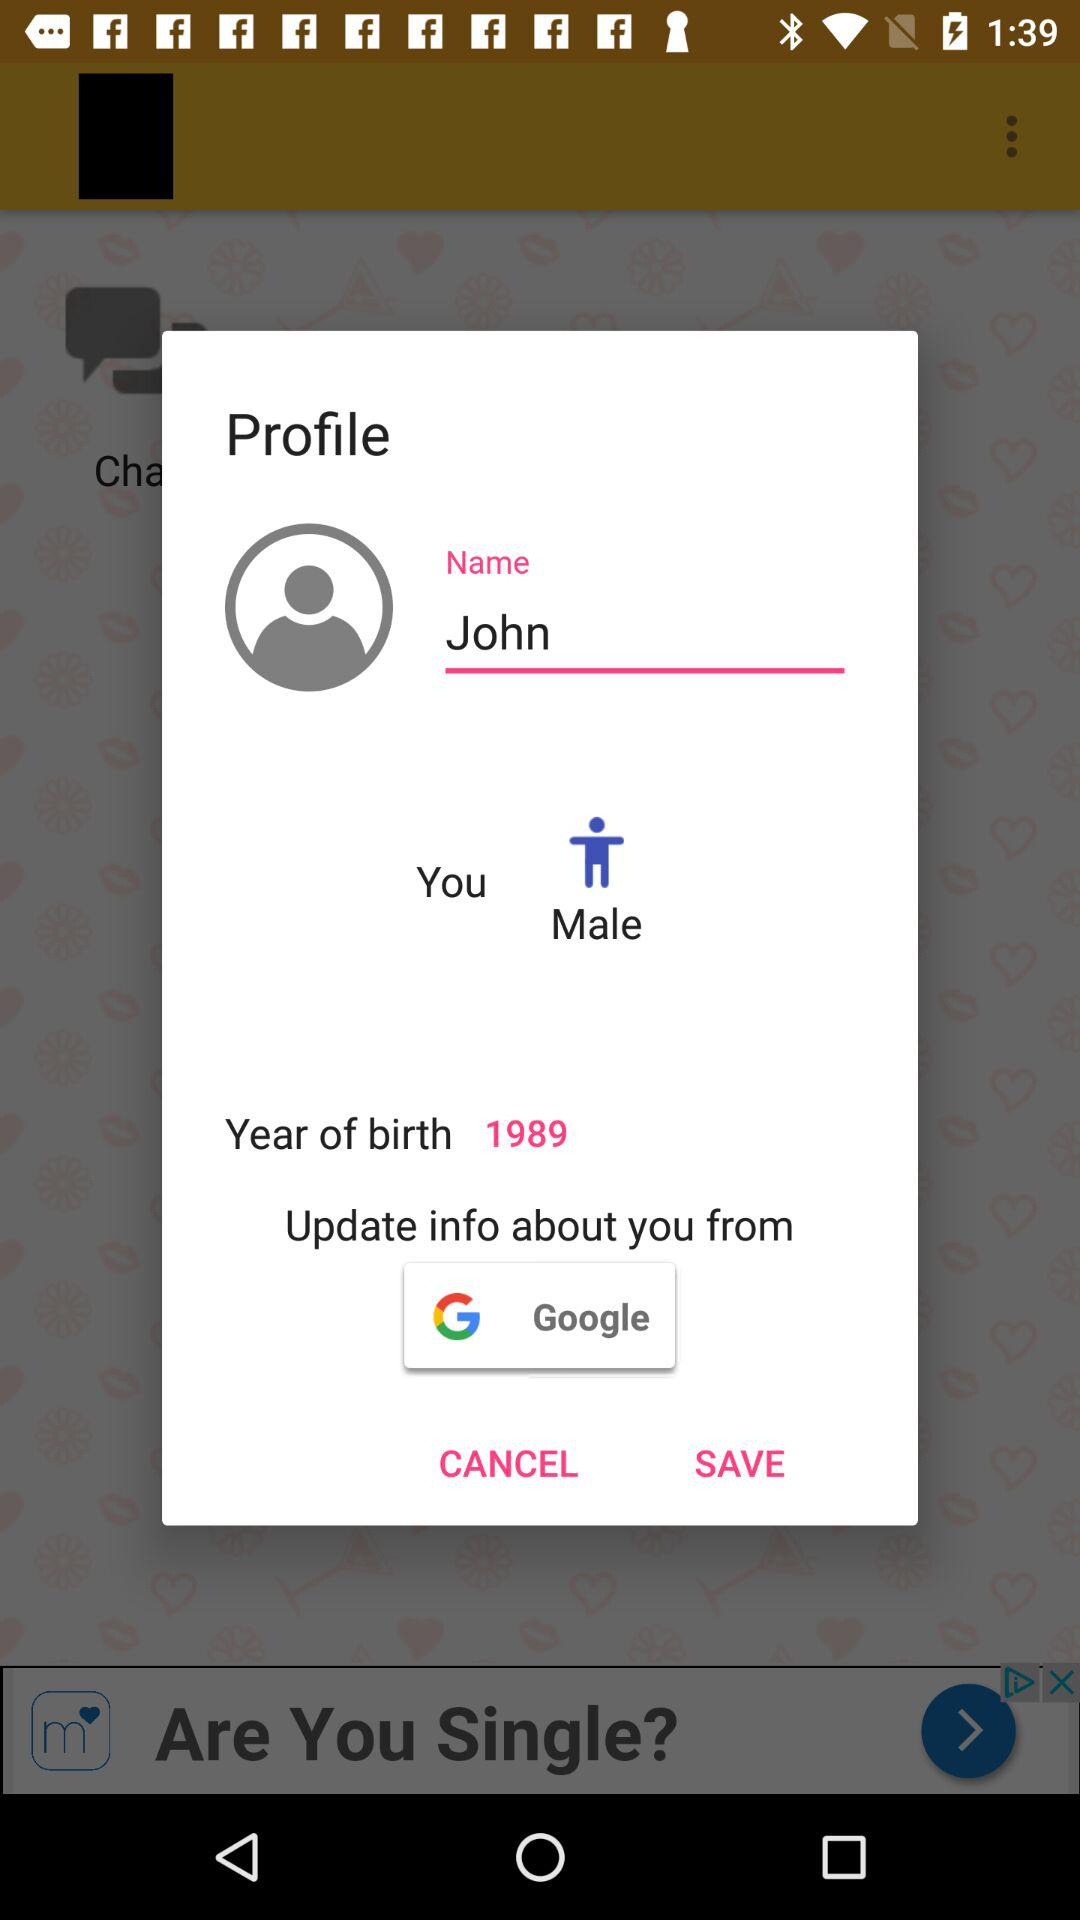What is the year of birth? The year of birth is 1989. 